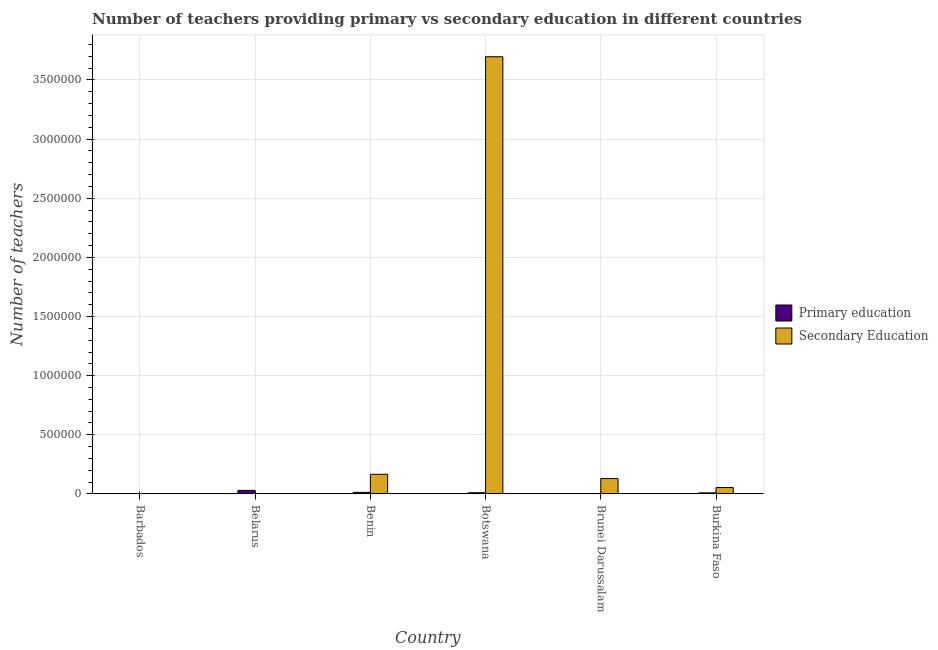How many different coloured bars are there?
Provide a succinct answer. 2. Are the number of bars per tick equal to the number of legend labels?
Make the answer very short. Yes. How many bars are there on the 5th tick from the right?
Keep it short and to the point. 2. What is the label of the 1st group of bars from the left?
Offer a very short reply. Barbados. In how many cases, is the number of bars for a given country not equal to the number of legend labels?
Offer a terse response. 0. What is the number of primary teachers in Burkina Faso?
Keep it short and to the point. 9165. Across all countries, what is the maximum number of secondary teachers?
Offer a terse response. 3.70e+06. Across all countries, what is the minimum number of primary teachers?
Keep it short and to the point. 1553. In which country was the number of primary teachers maximum?
Your answer should be very brief. Belarus. In which country was the number of secondary teachers minimum?
Provide a succinct answer. Belarus. What is the total number of secondary teachers in the graph?
Offer a very short reply. 4.05e+06. What is the difference between the number of primary teachers in Barbados and that in Brunei Darussalam?
Ensure brevity in your answer.  -1008. What is the difference between the number of secondary teachers in Burkina Faso and the number of primary teachers in Belarus?
Your response must be concise. 2.41e+04. What is the average number of primary teachers per country?
Provide a short and direct response. 1.12e+04. What is the difference between the number of secondary teachers and number of primary teachers in Belarus?
Keep it short and to the point. -2.81e+04. What is the ratio of the number of secondary teachers in Benin to that in Brunei Darussalam?
Keep it short and to the point. 1.28. Is the difference between the number of secondary teachers in Belarus and Burkina Faso greater than the difference between the number of primary teachers in Belarus and Burkina Faso?
Ensure brevity in your answer.  No. What is the difference between the highest and the second highest number of primary teachers?
Make the answer very short. 1.69e+04. What is the difference between the highest and the lowest number of primary teachers?
Your response must be concise. 2.87e+04. What does the 2nd bar from the left in Burkina Faso represents?
Your response must be concise. Secondary Education. What does the 1st bar from the right in Botswana represents?
Ensure brevity in your answer.  Secondary Education. Are all the bars in the graph horizontal?
Ensure brevity in your answer.  No. Does the graph contain any zero values?
Your response must be concise. No. Does the graph contain grids?
Offer a terse response. Yes. Where does the legend appear in the graph?
Offer a very short reply. Center right. How many legend labels are there?
Your response must be concise. 2. How are the legend labels stacked?
Offer a terse response. Vertical. What is the title of the graph?
Give a very brief answer. Number of teachers providing primary vs secondary education in different countries. Does "Ages 15-24" appear as one of the legend labels in the graph?
Make the answer very short. No. What is the label or title of the Y-axis?
Provide a short and direct response. Number of teachers. What is the Number of teachers in Primary education in Barbados?
Provide a succinct answer. 1553. What is the Number of teachers of Secondary Education in Barbados?
Offer a terse response. 2248. What is the Number of teachers of Primary education in Belarus?
Your response must be concise. 3.03e+04. What is the Number of teachers of Secondary Education in Belarus?
Keep it short and to the point. 2211. What is the Number of teachers of Primary education in Benin?
Give a very brief answer. 1.34e+04. What is the Number of teachers in Secondary Education in Benin?
Offer a terse response. 1.66e+05. What is the Number of teachers of Primary education in Botswana?
Your answer should be compact. 1.05e+04. What is the Number of teachers in Secondary Education in Botswana?
Provide a short and direct response. 3.70e+06. What is the Number of teachers of Primary education in Brunei Darussalam?
Offer a terse response. 2561. What is the Number of teachers of Secondary Education in Brunei Darussalam?
Give a very brief answer. 1.31e+05. What is the Number of teachers in Primary education in Burkina Faso?
Offer a terse response. 9165. What is the Number of teachers in Secondary Education in Burkina Faso?
Your answer should be compact. 5.44e+04. Across all countries, what is the maximum Number of teachers in Primary education?
Keep it short and to the point. 3.03e+04. Across all countries, what is the maximum Number of teachers of Secondary Education?
Provide a succinct answer. 3.70e+06. Across all countries, what is the minimum Number of teachers of Primary education?
Provide a succinct answer. 1553. Across all countries, what is the minimum Number of teachers in Secondary Education?
Ensure brevity in your answer.  2211. What is the total Number of teachers in Primary education in the graph?
Make the answer very short. 6.75e+04. What is the total Number of teachers of Secondary Education in the graph?
Make the answer very short. 4.05e+06. What is the difference between the Number of teachers in Primary education in Barbados and that in Belarus?
Ensure brevity in your answer.  -2.87e+04. What is the difference between the Number of teachers of Secondary Education in Barbados and that in Belarus?
Make the answer very short. 37. What is the difference between the Number of teachers in Primary education in Barbados and that in Benin?
Keep it short and to the point. -1.19e+04. What is the difference between the Number of teachers in Secondary Education in Barbados and that in Benin?
Keep it short and to the point. -1.64e+05. What is the difference between the Number of teachers of Primary education in Barbados and that in Botswana?
Provide a succinct answer. -8910. What is the difference between the Number of teachers in Secondary Education in Barbados and that in Botswana?
Provide a succinct answer. -3.69e+06. What is the difference between the Number of teachers in Primary education in Barbados and that in Brunei Darussalam?
Provide a short and direct response. -1008. What is the difference between the Number of teachers of Secondary Education in Barbados and that in Brunei Darussalam?
Provide a short and direct response. -1.28e+05. What is the difference between the Number of teachers in Primary education in Barbados and that in Burkina Faso?
Make the answer very short. -7612. What is the difference between the Number of teachers in Secondary Education in Barbados and that in Burkina Faso?
Keep it short and to the point. -5.21e+04. What is the difference between the Number of teachers in Primary education in Belarus and that in Benin?
Make the answer very short. 1.69e+04. What is the difference between the Number of teachers of Secondary Education in Belarus and that in Benin?
Ensure brevity in your answer.  -1.64e+05. What is the difference between the Number of teachers in Primary education in Belarus and that in Botswana?
Your response must be concise. 1.98e+04. What is the difference between the Number of teachers in Secondary Education in Belarus and that in Botswana?
Your answer should be compact. -3.69e+06. What is the difference between the Number of teachers of Primary education in Belarus and that in Brunei Darussalam?
Your answer should be very brief. 2.77e+04. What is the difference between the Number of teachers in Secondary Education in Belarus and that in Brunei Darussalam?
Give a very brief answer. -1.28e+05. What is the difference between the Number of teachers of Primary education in Belarus and that in Burkina Faso?
Make the answer very short. 2.11e+04. What is the difference between the Number of teachers of Secondary Education in Belarus and that in Burkina Faso?
Make the answer very short. -5.22e+04. What is the difference between the Number of teachers in Primary education in Benin and that in Botswana?
Your answer should be very brief. 2959. What is the difference between the Number of teachers in Secondary Education in Benin and that in Botswana?
Your response must be concise. -3.53e+06. What is the difference between the Number of teachers of Primary education in Benin and that in Brunei Darussalam?
Give a very brief answer. 1.09e+04. What is the difference between the Number of teachers of Secondary Education in Benin and that in Brunei Darussalam?
Your answer should be compact. 3.59e+04. What is the difference between the Number of teachers of Primary education in Benin and that in Burkina Faso?
Make the answer very short. 4257. What is the difference between the Number of teachers in Secondary Education in Benin and that in Burkina Faso?
Ensure brevity in your answer.  1.12e+05. What is the difference between the Number of teachers in Primary education in Botswana and that in Brunei Darussalam?
Provide a short and direct response. 7902. What is the difference between the Number of teachers of Secondary Education in Botswana and that in Brunei Darussalam?
Give a very brief answer. 3.57e+06. What is the difference between the Number of teachers in Primary education in Botswana and that in Burkina Faso?
Make the answer very short. 1298. What is the difference between the Number of teachers in Secondary Education in Botswana and that in Burkina Faso?
Offer a very short reply. 3.64e+06. What is the difference between the Number of teachers of Primary education in Brunei Darussalam and that in Burkina Faso?
Offer a very short reply. -6604. What is the difference between the Number of teachers in Secondary Education in Brunei Darussalam and that in Burkina Faso?
Provide a succinct answer. 7.61e+04. What is the difference between the Number of teachers in Primary education in Barbados and the Number of teachers in Secondary Education in Belarus?
Provide a succinct answer. -658. What is the difference between the Number of teachers of Primary education in Barbados and the Number of teachers of Secondary Education in Benin?
Your response must be concise. -1.65e+05. What is the difference between the Number of teachers in Primary education in Barbados and the Number of teachers in Secondary Education in Botswana?
Make the answer very short. -3.69e+06. What is the difference between the Number of teachers of Primary education in Barbados and the Number of teachers of Secondary Education in Brunei Darussalam?
Your response must be concise. -1.29e+05. What is the difference between the Number of teachers of Primary education in Barbados and the Number of teachers of Secondary Education in Burkina Faso?
Your answer should be very brief. -5.28e+04. What is the difference between the Number of teachers in Primary education in Belarus and the Number of teachers in Secondary Education in Benin?
Ensure brevity in your answer.  -1.36e+05. What is the difference between the Number of teachers in Primary education in Belarus and the Number of teachers in Secondary Education in Botswana?
Your response must be concise. -3.67e+06. What is the difference between the Number of teachers of Primary education in Belarus and the Number of teachers of Secondary Education in Brunei Darussalam?
Keep it short and to the point. -1.00e+05. What is the difference between the Number of teachers of Primary education in Belarus and the Number of teachers of Secondary Education in Burkina Faso?
Your answer should be compact. -2.41e+04. What is the difference between the Number of teachers of Primary education in Benin and the Number of teachers of Secondary Education in Botswana?
Offer a very short reply. -3.68e+06. What is the difference between the Number of teachers in Primary education in Benin and the Number of teachers in Secondary Education in Brunei Darussalam?
Provide a succinct answer. -1.17e+05. What is the difference between the Number of teachers of Primary education in Benin and the Number of teachers of Secondary Education in Burkina Faso?
Provide a succinct answer. -4.10e+04. What is the difference between the Number of teachers of Primary education in Botswana and the Number of teachers of Secondary Education in Brunei Darussalam?
Your response must be concise. -1.20e+05. What is the difference between the Number of teachers of Primary education in Botswana and the Number of teachers of Secondary Education in Burkina Faso?
Give a very brief answer. -4.39e+04. What is the difference between the Number of teachers of Primary education in Brunei Darussalam and the Number of teachers of Secondary Education in Burkina Faso?
Offer a terse response. -5.18e+04. What is the average Number of teachers in Primary education per country?
Offer a very short reply. 1.12e+04. What is the average Number of teachers in Secondary Education per country?
Ensure brevity in your answer.  6.75e+05. What is the difference between the Number of teachers of Primary education and Number of teachers of Secondary Education in Barbados?
Offer a very short reply. -695. What is the difference between the Number of teachers in Primary education and Number of teachers in Secondary Education in Belarus?
Give a very brief answer. 2.81e+04. What is the difference between the Number of teachers of Primary education and Number of teachers of Secondary Education in Benin?
Provide a short and direct response. -1.53e+05. What is the difference between the Number of teachers in Primary education and Number of teachers in Secondary Education in Botswana?
Your answer should be compact. -3.69e+06. What is the difference between the Number of teachers in Primary education and Number of teachers in Secondary Education in Brunei Darussalam?
Make the answer very short. -1.28e+05. What is the difference between the Number of teachers of Primary education and Number of teachers of Secondary Education in Burkina Faso?
Offer a terse response. -4.52e+04. What is the ratio of the Number of teachers of Primary education in Barbados to that in Belarus?
Your answer should be compact. 0.05. What is the ratio of the Number of teachers in Secondary Education in Barbados to that in Belarus?
Make the answer very short. 1.02. What is the ratio of the Number of teachers in Primary education in Barbados to that in Benin?
Your response must be concise. 0.12. What is the ratio of the Number of teachers of Secondary Education in Barbados to that in Benin?
Your response must be concise. 0.01. What is the ratio of the Number of teachers in Primary education in Barbados to that in Botswana?
Make the answer very short. 0.15. What is the ratio of the Number of teachers of Secondary Education in Barbados to that in Botswana?
Offer a very short reply. 0. What is the ratio of the Number of teachers of Primary education in Barbados to that in Brunei Darussalam?
Keep it short and to the point. 0.61. What is the ratio of the Number of teachers of Secondary Education in Barbados to that in Brunei Darussalam?
Provide a succinct answer. 0.02. What is the ratio of the Number of teachers in Primary education in Barbados to that in Burkina Faso?
Make the answer very short. 0.17. What is the ratio of the Number of teachers of Secondary Education in Barbados to that in Burkina Faso?
Your response must be concise. 0.04. What is the ratio of the Number of teachers of Primary education in Belarus to that in Benin?
Make the answer very short. 2.26. What is the ratio of the Number of teachers in Secondary Education in Belarus to that in Benin?
Ensure brevity in your answer.  0.01. What is the ratio of the Number of teachers in Primary education in Belarus to that in Botswana?
Offer a very short reply. 2.9. What is the ratio of the Number of teachers of Secondary Education in Belarus to that in Botswana?
Your answer should be compact. 0. What is the ratio of the Number of teachers in Primary education in Belarus to that in Brunei Darussalam?
Give a very brief answer. 11.83. What is the ratio of the Number of teachers of Secondary Education in Belarus to that in Brunei Darussalam?
Offer a very short reply. 0.02. What is the ratio of the Number of teachers of Primary education in Belarus to that in Burkina Faso?
Make the answer very short. 3.31. What is the ratio of the Number of teachers in Secondary Education in Belarus to that in Burkina Faso?
Provide a short and direct response. 0.04. What is the ratio of the Number of teachers in Primary education in Benin to that in Botswana?
Your answer should be compact. 1.28. What is the ratio of the Number of teachers of Secondary Education in Benin to that in Botswana?
Your response must be concise. 0.04. What is the ratio of the Number of teachers in Primary education in Benin to that in Brunei Darussalam?
Make the answer very short. 5.24. What is the ratio of the Number of teachers of Secondary Education in Benin to that in Brunei Darussalam?
Ensure brevity in your answer.  1.27. What is the ratio of the Number of teachers in Primary education in Benin to that in Burkina Faso?
Give a very brief answer. 1.46. What is the ratio of the Number of teachers of Secondary Education in Benin to that in Burkina Faso?
Provide a succinct answer. 3.06. What is the ratio of the Number of teachers of Primary education in Botswana to that in Brunei Darussalam?
Your answer should be compact. 4.09. What is the ratio of the Number of teachers of Secondary Education in Botswana to that in Brunei Darussalam?
Keep it short and to the point. 28.32. What is the ratio of the Number of teachers in Primary education in Botswana to that in Burkina Faso?
Provide a succinct answer. 1.14. What is the ratio of the Number of teachers in Secondary Education in Botswana to that in Burkina Faso?
Ensure brevity in your answer.  67.96. What is the ratio of the Number of teachers in Primary education in Brunei Darussalam to that in Burkina Faso?
Give a very brief answer. 0.28. What is the ratio of the Number of teachers of Secondary Education in Brunei Darussalam to that in Burkina Faso?
Provide a succinct answer. 2.4. What is the difference between the highest and the second highest Number of teachers in Primary education?
Offer a terse response. 1.69e+04. What is the difference between the highest and the second highest Number of teachers of Secondary Education?
Ensure brevity in your answer.  3.53e+06. What is the difference between the highest and the lowest Number of teachers of Primary education?
Provide a short and direct response. 2.87e+04. What is the difference between the highest and the lowest Number of teachers in Secondary Education?
Provide a succinct answer. 3.69e+06. 